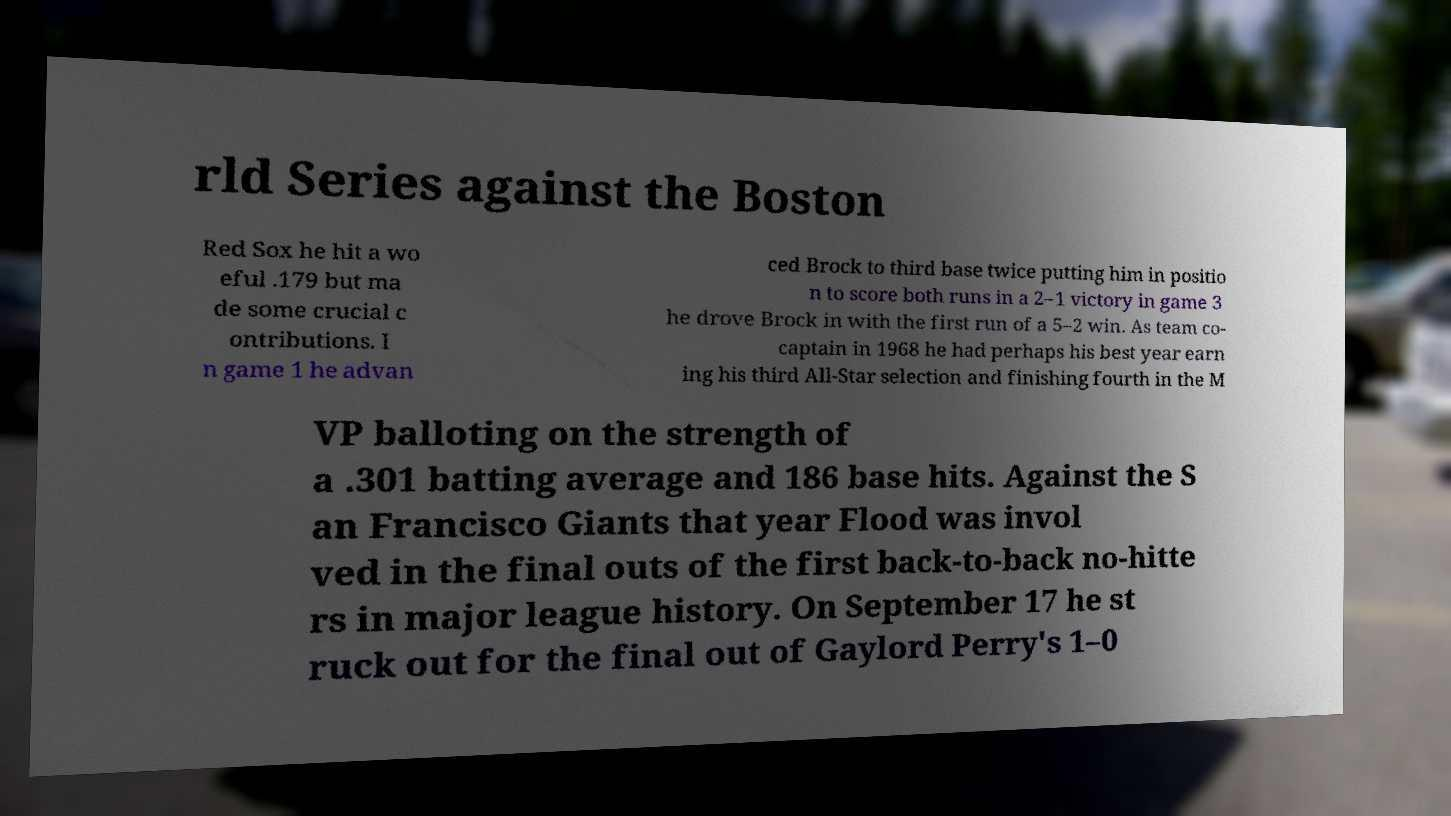Can you read and provide the text displayed in the image?This photo seems to have some interesting text. Can you extract and type it out for me? rld Series against the Boston Red Sox he hit a wo eful .179 but ma de some crucial c ontributions. I n game 1 he advan ced Brock to third base twice putting him in positio n to score both runs in a 2–1 victory in game 3 he drove Brock in with the first run of a 5–2 win. As team co- captain in 1968 he had perhaps his best year earn ing his third All-Star selection and finishing fourth in the M VP balloting on the strength of a .301 batting average and 186 base hits. Against the S an Francisco Giants that year Flood was invol ved in the final outs of the first back-to-back no-hitte rs in major league history. On September 17 he st ruck out for the final out of Gaylord Perry's 1–0 